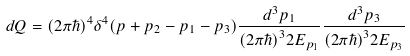<formula> <loc_0><loc_0><loc_500><loc_500>d Q = ( 2 \pi \hbar { ) } ^ { 4 } \delta ^ { 4 } ( p + p _ { 2 } - p _ { 1 } - p _ { 3 } ) \frac { d ^ { 3 } p _ { 1 } } { ( 2 \pi \hbar { ) } ^ { 3 } 2 E _ { p _ { 1 } } } \frac { d ^ { 3 } p _ { 3 } } { ( 2 \pi \hbar { ) } ^ { 3 } 2 E _ { p _ { 3 } } }</formula> 